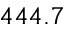<formula> <loc_0><loc_0><loc_500><loc_500>4 4 4 . 7</formula> 